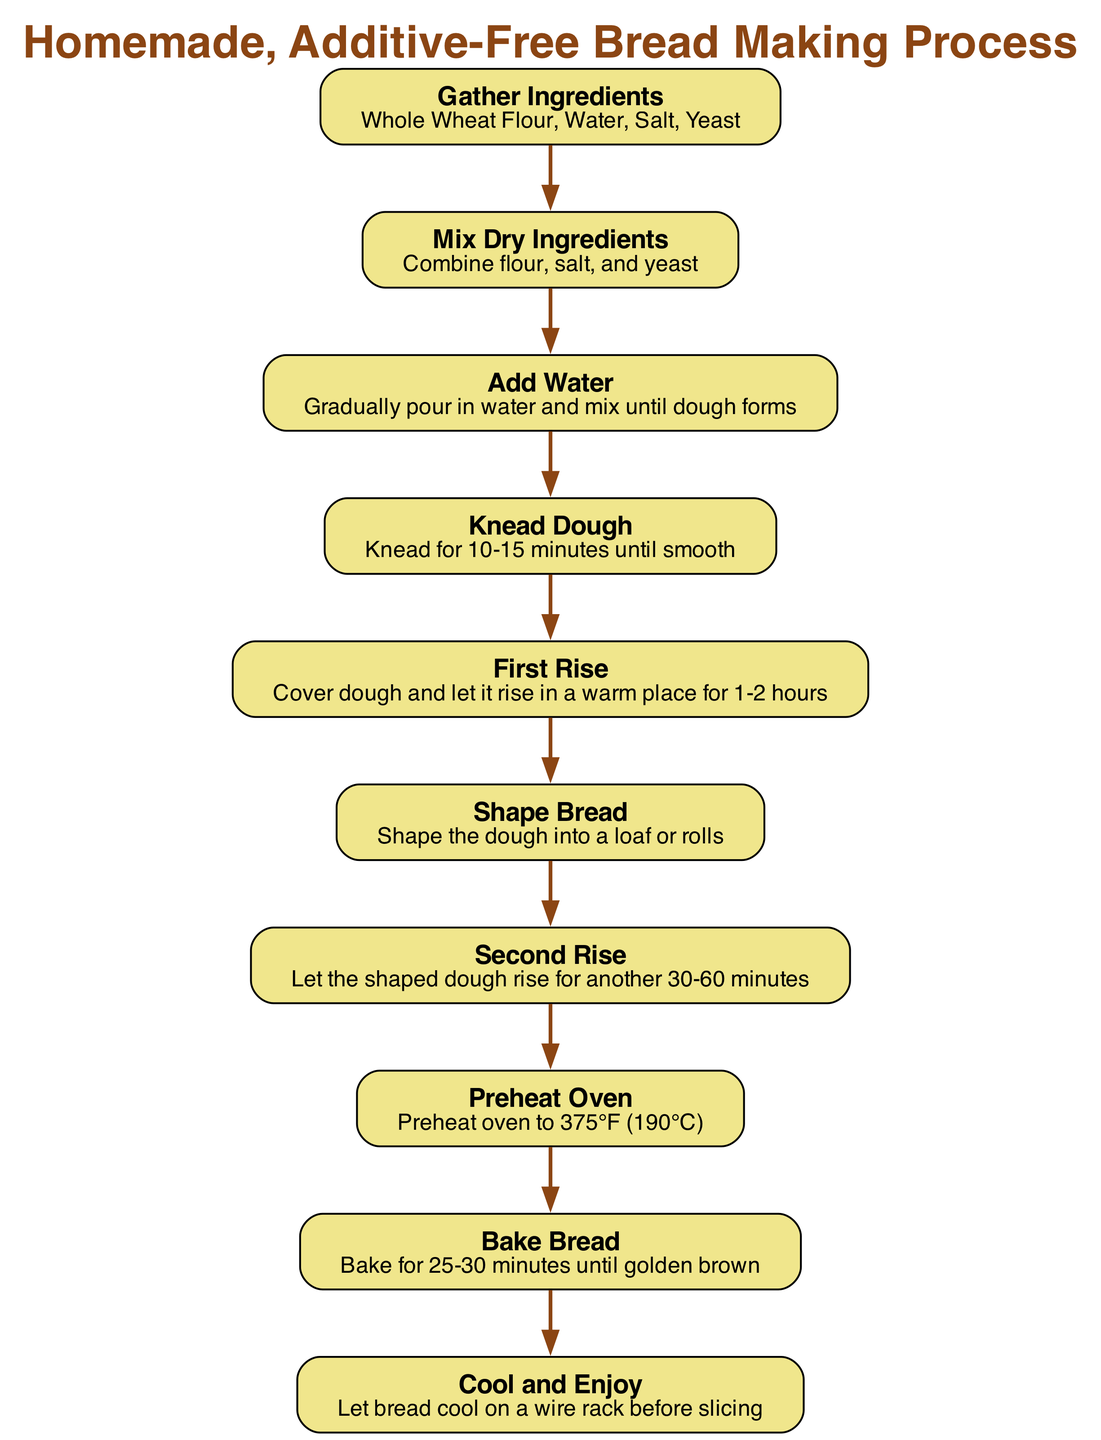What is the first step in the bread-making process? The first step listed in the diagram is "Gather Ingredients," which refers to collecting all necessary components for bread-making.
Answer: Gather Ingredients How many main ingredients are required? The diagram lists four main ingredients: Whole Wheat Flour, Water, Salt, and Yeast, which are highlighted in the "Gather Ingredients" node.
Answer: Four What action is required after mixing dry ingredients? After mixing the dry ingredients, the next step as per the flow chart is to "Add Water." This follows the logical sequence of combining ingredients to form dough.
Answer: Add Water How long should the dough rise for the first time? According to the "First Rise" step in the flow chart, the dough should be covered and allowed to rise in a warm place for 1-2 hours. This duration is specified clearly in that step.
Answer: 1-2 hours What is the temperature to preheat the oven? The "Preheat Oven" step specifies that the oven needs to be set to 375°F (190°C), indicating the necessary conditions for baking the bread optimally.
Answer: 375°F (190°C) What is the minimum baking time listed in the diagram? In the "Bake Bread" step, it states that the bread should be baked for at least 25 minutes. This is the minimum time required for achieving a golden brown finish.
Answer: 25 minutes Which step follows after kneading the dough? Following the "Knead Dough" step, the next action is the "First Rise," where the kneaded dough is allowed to rise. This creates a sequence where the dough must first be prepared before it can rise.
Answer: First Rise How much time should the shaped dough rise for the second time? The diagram states that after shaping the bread, it needs a second rise of 30-60 minutes. This is clearly outlined in the "Second Rise" step.
Answer: 30-60 minutes What should you do after baking the bread? The last step in the flow chart is "Cool and Enjoy," indicating that once the bread is baked, it must cool on a wire rack before slicing, completing the preparation process.
Answer: Cool and Enjoy 